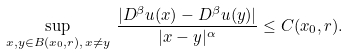Convert formula to latex. <formula><loc_0><loc_0><loc_500><loc_500>\sup _ { x , y \in B ( x _ { 0 } , r ) , \, x \neq y } \, \frac { | D ^ { \beta } u ( x ) - D ^ { \beta } u ( y ) | } { | x - y | ^ { \alpha } } \leq C ( x _ { 0 } , r ) .</formula> 